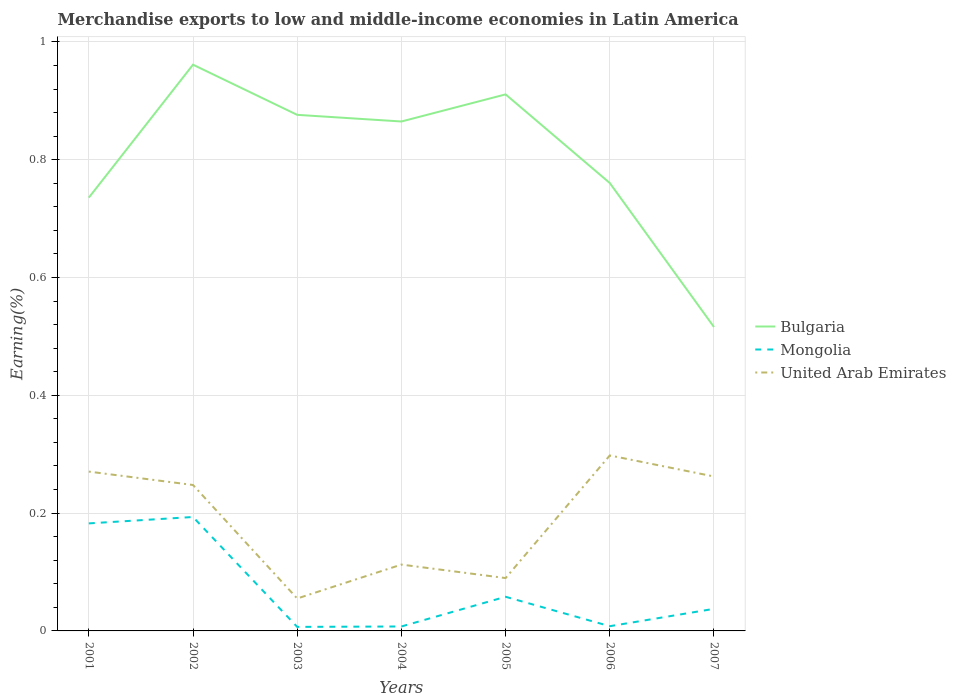How many different coloured lines are there?
Offer a very short reply. 3. Does the line corresponding to Bulgaria intersect with the line corresponding to United Arab Emirates?
Give a very brief answer. No. Is the number of lines equal to the number of legend labels?
Your answer should be compact. Yes. Across all years, what is the maximum percentage of amount earned from merchandise exports in United Arab Emirates?
Ensure brevity in your answer.  0.06. In which year was the percentage of amount earned from merchandise exports in United Arab Emirates maximum?
Provide a short and direct response. 2003. What is the total percentage of amount earned from merchandise exports in Mongolia in the graph?
Give a very brief answer. 0.02. What is the difference between the highest and the second highest percentage of amount earned from merchandise exports in Mongolia?
Offer a terse response. 0.19. Is the percentage of amount earned from merchandise exports in Bulgaria strictly greater than the percentage of amount earned from merchandise exports in United Arab Emirates over the years?
Keep it short and to the point. No. How many years are there in the graph?
Provide a short and direct response. 7. What is the difference between two consecutive major ticks on the Y-axis?
Provide a short and direct response. 0.2. How many legend labels are there?
Ensure brevity in your answer.  3. How are the legend labels stacked?
Make the answer very short. Vertical. What is the title of the graph?
Provide a short and direct response. Merchandise exports to low and middle-income economies in Latin America. Does "Madagascar" appear as one of the legend labels in the graph?
Your answer should be very brief. No. What is the label or title of the Y-axis?
Offer a terse response. Earning(%). What is the Earning(%) of Bulgaria in 2001?
Provide a succinct answer. 0.74. What is the Earning(%) of Mongolia in 2001?
Offer a terse response. 0.18. What is the Earning(%) in United Arab Emirates in 2001?
Make the answer very short. 0.27. What is the Earning(%) of Bulgaria in 2002?
Keep it short and to the point. 0.96. What is the Earning(%) in Mongolia in 2002?
Ensure brevity in your answer.  0.19. What is the Earning(%) in United Arab Emirates in 2002?
Offer a very short reply. 0.25. What is the Earning(%) in Bulgaria in 2003?
Ensure brevity in your answer.  0.88. What is the Earning(%) in Mongolia in 2003?
Offer a very short reply. 0.01. What is the Earning(%) in United Arab Emirates in 2003?
Your answer should be very brief. 0.06. What is the Earning(%) of Bulgaria in 2004?
Provide a short and direct response. 0.86. What is the Earning(%) in Mongolia in 2004?
Give a very brief answer. 0.01. What is the Earning(%) of United Arab Emirates in 2004?
Ensure brevity in your answer.  0.11. What is the Earning(%) of Bulgaria in 2005?
Ensure brevity in your answer.  0.91. What is the Earning(%) of Mongolia in 2005?
Provide a succinct answer. 0.06. What is the Earning(%) in United Arab Emirates in 2005?
Make the answer very short. 0.09. What is the Earning(%) of Bulgaria in 2006?
Ensure brevity in your answer.  0.76. What is the Earning(%) of Mongolia in 2006?
Keep it short and to the point. 0.01. What is the Earning(%) in United Arab Emirates in 2006?
Provide a short and direct response. 0.3. What is the Earning(%) in Bulgaria in 2007?
Your response must be concise. 0.52. What is the Earning(%) in Mongolia in 2007?
Offer a very short reply. 0.04. What is the Earning(%) of United Arab Emirates in 2007?
Provide a succinct answer. 0.26. Across all years, what is the maximum Earning(%) in Bulgaria?
Provide a short and direct response. 0.96. Across all years, what is the maximum Earning(%) of Mongolia?
Make the answer very short. 0.19. Across all years, what is the maximum Earning(%) of United Arab Emirates?
Offer a very short reply. 0.3. Across all years, what is the minimum Earning(%) in Bulgaria?
Give a very brief answer. 0.52. Across all years, what is the minimum Earning(%) in Mongolia?
Your response must be concise. 0.01. Across all years, what is the minimum Earning(%) in United Arab Emirates?
Make the answer very short. 0.06. What is the total Earning(%) in Bulgaria in the graph?
Give a very brief answer. 5.62. What is the total Earning(%) of Mongolia in the graph?
Keep it short and to the point. 0.49. What is the total Earning(%) in United Arab Emirates in the graph?
Provide a short and direct response. 1.34. What is the difference between the Earning(%) of Bulgaria in 2001 and that in 2002?
Provide a short and direct response. -0.23. What is the difference between the Earning(%) of Mongolia in 2001 and that in 2002?
Provide a short and direct response. -0.01. What is the difference between the Earning(%) of United Arab Emirates in 2001 and that in 2002?
Your response must be concise. 0.02. What is the difference between the Earning(%) in Bulgaria in 2001 and that in 2003?
Your answer should be compact. -0.14. What is the difference between the Earning(%) of Mongolia in 2001 and that in 2003?
Your answer should be very brief. 0.18. What is the difference between the Earning(%) in United Arab Emirates in 2001 and that in 2003?
Your answer should be compact. 0.22. What is the difference between the Earning(%) of Bulgaria in 2001 and that in 2004?
Your answer should be compact. -0.13. What is the difference between the Earning(%) in Mongolia in 2001 and that in 2004?
Keep it short and to the point. 0.17. What is the difference between the Earning(%) of United Arab Emirates in 2001 and that in 2004?
Your response must be concise. 0.16. What is the difference between the Earning(%) of Bulgaria in 2001 and that in 2005?
Make the answer very short. -0.18. What is the difference between the Earning(%) of Mongolia in 2001 and that in 2005?
Ensure brevity in your answer.  0.12. What is the difference between the Earning(%) in United Arab Emirates in 2001 and that in 2005?
Offer a very short reply. 0.18. What is the difference between the Earning(%) of Bulgaria in 2001 and that in 2006?
Provide a succinct answer. -0.02. What is the difference between the Earning(%) in Mongolia in 2001 and that in 2006?
Your answer should be very brief. 0.17. What is the difference between the Earning(%) in United Arab Emirates in 2001 and that in 2006?
Keep it short and to the point. -0.03. What is the difference between the Earning(%) in Bulgaria in 2001 and that in 2007?
Provide a succinct answer. 0.22. What is the difference between the Earning(%) in Mongolia in 2001 and that in 2007?
Offer a very short reply. 0.15. What is the difference between the Earning(%) of United Arab Emirates in 2001 and that in 2007?
Offer a terse response. 0.01. What is the difference between the Earning(%) in Bulgaria in 2002 and that in 2003?
Give a very brief answer. 0.09. What is the difference between the Earning(%) of Mongolia in 2002 and that in 2003?
Make the answer very short. 0.19. What is the difference between the Earning(%) in United Arab Emirates in 2002 and that in 2003?
Your answer should be very brief. 0.19. What is the difference between the Earning(%) of Bulgaria in 2002 and that in 2004?
Ensure brevity in your answer.  0.1. What is the difference between the Earning(%) in Mongolia in 2002 and that in 2004?
Keep it short and to the point. 0.19. What is the difference between the Earning(%) in United Arab Emirates in 2002 and that in 2004?
Your response must be concise. 0.14. What is the difference between the Earning(%) in Bulgaria in 2002 and that in 2005?
Offer a very short reply. 0.05. What is the difference between the Earning(%) in Mongolia in 2002 and that in 2005?
Provide a short and direct response. 0.14. What is the difference between the Earning(%) of United Arab Emirates in 2002 and that in 2005?
Your answer should be very brief. 0.16. What is the difference between the Earning(%) of Bulgaria in 2002 and that in 2006?
Ensure brevity in your answer.  0.2. What is the difference between the Earning(%) in Mongolia in 2002 and that in 2006?
Your response must be concise. 0.19. What is the difference between the Earning(%) in United Arab Emirates in 2002 and that in 2006?
Make the answer very short. -0.05. What is the difference between the Earning(%) of Bulgaria in 2002 and that in 2007?
Give a very brief answer. 0.45. What is the difference between the Earning(%) in Mongolia in 2002 and that in 2007?
Your answer should be very brief. 0.16. What is the difference between the Earning(%) of United Arab Emirates in 2002 and that in 2007?
Offer a terse response. -0.01. What is the difference between the Earning(%) in Bulgaria in 2003 and that in 2004?
Make the answer very short. 0.01. What is the difference between the Earning(%) of Mongolia in 2003 and that in 2004?
Provide a succinct answer. -0. What is the difference between the Earning(%) of United Arab Emirates in 2003 and that in 2004?
Provide a short and direct response. -0.06. What is the difference between the Earning(%) of Bulgaria in 2003 and that in 2005?
Provide a succinct answer. -0.03. What is the difference between the Earning(%) in Mongolia in 2003 and that in 2005?
Offer a terse response. -0.05. What is the difference between the Earning(%) of United Arab Emirates in 2003 and that in 2005?
Ensure brevity in your answer.  -0.03. What is the difference between the Earning(%) of Bulgaria in 2003 and that in 2006?
Your response must be concise. 0.12. What is the difference between the Earning(%) of Mongolia in 2003 and that in 2006?
Provide a succinct answer. -0. What is the difference between the Earning(%) of United Arab Emirates in 2003 and that in 2006?
Your answer should be very brief. -0.24. What is the difference between the Earning(%) in Bulgaria in 2003 and that in 2007?
Keep it short and to the point. 0.36. What is the difference between the Earning(%) in Mongolia in 2003 and that in 2007?
Your answer should be very brief. -0.03. What is the difference between the Earning(%) in United Arab Emirates in 2003 and that in 2007?
Provide a short and direct response. -0.21. What is the difference between the Earning(%) in Bulgaria in 2004 and that in 2005?
Offer a terse response. -0.05. What is the difference between the Earning(%) of Mongolia in 2004 and that in 2005?
Provide a succinct answer. -0.05. What is the difference between the Earning(%) of United Arab Emirates in 2004 and that in 2005?
Offer a very short reply. 0.02. What is the difference between the Earning(%) in Bulgaria in 2004 and that in 2006?
Your answer should be compact. 0.1. What is the difference between the Earning(%) in Mongolia in 2004 and that in 2006?
Provide a succinct answer. -0. What is the difference between the Earning(%) in United Arab Emirates in 2004 and that in 2006?
Your response must be concise. -0.19. What is the difference between the Earning(%) in Bulgaria in 2004 and that in 2007?
Keep it short and to the point. 0.35. What is the difference between the Earning(%) in Mongolia in 2004 and that in 2007?
Make the answer very short. -0.03. What is the difference between the Earning(%) in United Arab Emirates in 2004 and that in 2007?
Your response must be concise. -0.15. What is the difference between the Earning(%) of Bulgaria in 2005 and that in 2006?
Provide a short and direct response. 0.15. What is the difference between the Earning(%) of Mongolia in 2005 and that in 2006?
Keep it short and to the point. 0.05. What is the difference between the Earning(%) in United Arab Emirates in 2005 and that in 2006?
Your answer should be compact. -0.21. What is the difference between the Earning(%) of Bulgaria in 2005 and that in 2007?
Make the answer very short. 0.4. What is the difference between the Earning(%) in Mongolia in 2005 and that in 2007?
Provide a succinct answer. 0.02. What is the difference between the Earning(%) of United Arab Emirates in 2005 and that in 2007?
Provide a short and direct response. -0.17. What is the difference between the Earning(%) of Bulgaria in 2006 and that in 2007?
Your response must be concise. 0.24. What is the difference between the Earning(%) of Mongolia in 2006 and that in 2007?
Your answer should be compact. -0.03. What is the difference between the Earning(%) of United Arab Emirates in 2006 and that in 2007?
Keep it short and to the point. 0.04. What is the difference between the Earning(%) in Bulgaria in 2001 and the Earning(%) in Mongolia in 2002?
Offer a very short reply. 0.54. What is the difference between the Earning(%) of Bulgaria in 2001 and the Earning(%) of United Arab Emirates in 2002?
Your answer should be very brief. 0.49. What is the difference between the Earning(%) in Mongolia in 2001 and the Earning(%) in United Arab Emirates in 2002?
Provide a short and direct response. -0.07. What is the difference between the Earning(%) of Bulgaria in 2001 and the Earning(%) of Mongolia in 2003?
Give a very brief answer. 0.73. What is the difference between the Earning(%) in Bulgaria in 2001 and the Earning(%) in United Arab Emirates in 2003?
Provide a short and direct response. 0.68. What is the difference between the Earning(%) in Mongolia in 2001 and the Earning(%) in United Arab Emirates in 2003?
Your response must be concise. 0.13. What is the difference between the Earning(%) of Bulgaria in 2001 and the Earning(%) of Mongolia in 2004?
Offer a terse response. 0.73. What is the difference between the Earning(%) of Bulgaria in 2001 and the Earning(%) of United Arab Emirates in 2004?
Offer a very short reply. 0.62. What is the difference between the Earning(%) in Mongolia in 2001 and the Earning(%) in United Arab Emirates in 2004?
Ensure brevity in your answer.  0.07. What is the difference between the Earning(%) of Bulgaria in 2001 and the Earning(%) of Mongolia in 2005?
Your response must be concise. 0.68. What is the difference between the Earning(%) of Bulgaria in 2001 and the Earning(%) of United Arab Emirates in 2005?
Your answer should be very brief. 0.65. What is the difference between the Earning(%) in Mongolia in 2001 and the Earning(%) in United Arab Emirates in 2005?
Provide a succinct answer. 0.09. What is the difference between the Earning(%) in Bulgaria in 2001 and the Earning(%) in Mongolia in 2006?
Offer a very short reply. 0.73. What is the difference between the Earning(%) of Bulgaria in 2001 and the Earning(%) of United Arab Emirates in 2006?
Offer a terse response. 0.44. What is the difference between the Earning(%) of Mongolia in 2001 and the Earning(%) of United Arab Emirates in 2006?
Ensure brevity in your answer.  -0.12. What is the difference between the Earning(%) in Bulgaria in 2001 and the Earning(%) in Mongolia in 2007?
Offer a terse response. 0.7. What is the difference between the Earning(%) of Bulgaria in 2001 and the Earning(%) of United Arab Emirates in 2007?
Your answer should be very brief. 0.47. What is the difference between the Earning(%) in Mongolia in 2001 and the Earning(%) in United Arab Emirates in 2007?
Offer a very short reply. -0.08. What is the difference between the Earning(%) of Bulgaria in 2002 and the Earning(%) of Mongolia in 2003?
Ensure brevity in your answer.  0.95. What is the difference between the Earning(%) in Bulgaria in 2002 and the Earning(%) in United Arab Emirates in 2003?
Give a very brief answer. 0.91. What is the difference between the Earning(%) in Mongolia in 2002 and the Earning(%) in United Arab Emirates in 2003?
Provide a short and direct response. 0.14. What is the difference between the Earning(%) in Bulgaria in 2002 and the Earning(%) in Mongolia in 2004?
Provide a short and direct response. 0.95. What is the difference between the Earning(%) in Bulgaria in 2002 and the Earning(%) in United Arab Emirates in 2004?
Your response must be concise. 0.85. What is the difference between the Earning(%) in Mongolia in 2002 and the Earning(%) in United Arab Emirates in 2004?
Give a very brief answer. 0.08. What is the difference between the Earning(%) in Bulgaria in 2002 and the Earning(%) in Mongolia in 2005?
Offer a terse response. 0.9. What is the difference between the Earning(%) in Bulgaria in 2002 and the Earning(%) in United Arab Emirates in 2005?
Give a very brief answer. 0.87. What is the difference between the Earning(%) in Mongolia in 2002 and the Earning(%) in United Arab Emirates in 2005?
Your answer should be compact. 0.1. What is the difference between the Earning(%) of Bulgaria in 2002 and the Earning(%) of Mongolia in 2006?
Ensure brevity in your answer.  0.95. What is the difference between the Earning(%) in Bulgaria in 2002 and the Earning(%) in United Arab Emirates in 2006?
Make the answer very short. 0.66. What is the difference between the Earning(%) in Mongolia in 2002 and the Earning(%) in United Arab Emirates in 2006?
Ensure brevity in your answer.  -0.1. What is the difference between the Earning(%) of Bulgaria in 2002 and the Earning(%) of Mongolia in 2007?
Offer a terse response. 0.92. What is the difference between the Earning(%) of Bulgaria in 2002 and the Earning(%) of United Arab Emirates in 2007?
Your answer should be very brief. 0.7. What is the difference between the Earning(%) in Mongolia in 2002 and the Earning(%) in United Arab Emirates in 2007?
Keep it short and to the point. -0.07. What is the difference between the Earning(%) in Bulgaria in 2003 and the Earning(%) in Mongolia in 2004?
Make the answer very short. 0.87. What is the difference between the Earning(%) in Bulgaria in 2003 and the Earning(%) in United Arab Emirates in 2004?
Your answer should be very brief. 0.76. What is the difference between the Earning(%) of Mongolia in 2003 and the Earning(%) of United Arab Emirates in 2004?
Your answer should be very brief. -0.11. What is the difference between the Earning(%) in Bulgaria in 2003 and the Earning(%) in Mongolia in 2005?
Make the answer very short. 0.82. What is the difference between the Earning(%) in Bulgaria in 2003 and the Earning(%) in United Arab Emirates in 2005?
Keep it short and to the point. 0.79. What is the difference between the Earning(%) of Mongolia in 2003 and the Earning(%) of United Arab Emirates in 2005?
Keep it short and to the point. -0.08. What is the difference between the Earning(%) of Bulgaria in 2003 and the Earning(%) of Mongolia in 2006?
Offer a terse response. 0.87. What is the difference between the Earning(%) of Bulgaria in 2003 and the Earning(%) of United Arab Emirates in 2006?
Your answer should be very brief. 0.58. What is the difference between the Earning(%) in Mongolia in 2003 and the Earning(%) in United Arab Emirates in 2006?
Make the answer very short. -0.29. What is the difference between the Earning(%) of Bulgaria in 2003 and the Earning(%) of Mongolia in 2007?
Your answer should be very brief. 0.84. What is the difference between the Earning(%) in Bulgaria in 2003 and the Earning(%) in United Arab Emirates in 2007?
Your answer should be compact. 0.61. What is the difference between the Earning(%) of Mongolia in 2003 and the Earning(%) of United Arab Emirates in 2007?
Ensure brevity in your answer.  -0.26. What is the difference between the Earning(%) in Bulgaria in 2004 and the Earning(%) in Mongolia in 2005?
Your answer should be compact. 0.81. What is the difference between the Earning(%) of Bulgaria in 2004 and the Earning(%) of United Arab Emirates in 2005?
Keep it short and to the point. 0.78. What is the difference between the Earning(%) of Mongolia in 2004 and the Earning(%) of United Arab Emirates in 2005?
Offer a very short reply. -0.08. What is the difference between the Earning(%) of Bulgaria in 2004 and the Earning(%) of Mongolia in 2006?
Ensure brevity in your answer.  0.86. What is the difference between the Earning(%) in Bulgaria in 2004 and the Earning(%) in United Arab Emirates in 2006?
Provide a short and direct response. 0.57. What is the difference between the Earning(%) in Mongolia in 2004 and the Earning(%) in United Arab Emirates in 2006?
Your answer should be compact. -0.29. What is the difference between the Earning(%) in Bulgaria in 2004 and the Earning(%) in Mongolia in 2007?
Provide a succinct answer. 0.83. What is the difference between the Earning(%) of Bulgaria in 2004 and the Earning(%) of United Arab Emirates in 2007?
Keep it short and to the point. 0.6. What is the difference between the Earning(%) of Mongolia in 2004 and the Earning(%) of United Arab Emirates in 2007?
Make the answer very short. -0.25. What is the difference between the Earning(%) of Bulgaria in 2005 and the Earning(%) of Mongolia in 2006?
Keep it short and to the point. 0.9. What is the difference between the Earning(%) in Bulgaria in 2005 and the Earning(%) in United Arab Emirates in 2006?
Keep it short and to the point. 0.61. What is the difference between the Earning(%) in Mongolia in 2005 and the Earning(%) in United Arab Emirates in 2006?
Provide a succinct answer. -0.24. What is the difference between the Earning(%) in Bulgaria in 2005 and the Earning(%) in Mongolia in 2007?
Your response must be concise. 0.87. What is the difference between the Earning(%) in Bulgaria in 2005 and the Earning(%) in United Arab Emirates in 2007?
Your response must be concise. 0.65. What is the difference between the Earning(%) of Mongolia in 2005 and the Earning(%) of United Arab Emirates in 2007?
Your answer should be very brief. -0.2. What is the difference between the Earning(%) in Bulgaria in 2006 and the Earning(%) in Mongolia in 2007?
Your answer should be very brief. 0.72. What is the difference between the Earning(%) of Bulgaria in 2006 and the Earning(%) of United Arab Emirates in 2007?
Provide a succinct answer. 0.5. What is the difference between the Earning(%) of Mongolia in 2006 and the Earning(%) of United Arab Emirates in 2007?
Provide a succinct answer. -0.25. What is the average Earning(%) in Bulgaria per year?
Keep it short and to the point. 0.8. What is the average Earning(%) of Mongolia per year?
Your response must be concise. 0.07. What is the average Earning(%) of United Arab Emirates per year?
Ensure brevity in your answer.  0.19. In the year 2001, what is the difference between the Earning(%) of Bulgaria and Earning(%) of Mongolia?
Give a very brief answer. 0.55. In the year 2001, what is the difference between the Earning(%) of Bulgaria and Earning(%) of United Arab Emirates?
Ensure brevity in your answer.  0.47. In the year 2001, what is the difference between the Earning(%) of Mongolia and Earning(%) of United Arab Emirates?
Give a very brief answer. -0.09. In the year 2002, what is the difference between the Earning(%) in Bulgaria and Earning(%) in Mongolia?
Keep it short and to the point. 0.77. In the year 2002, what is the difference between the Earning(%) of Bulgaria and Earning(%) of United Arab Emirates?
Provide a succinct answer. 0.71. In the year 2002, what is the difference between the Earning(%) in Mongolia and Earning(%) in United Arab Emirates?
Make the answer very short. -0.05. In the year 2003, what is the difference between the Earning(%) in Bulgaria and Earning(%) in Mongolia?
Your answer should be compact. 0.87. In the year 2003, what is the difference between the Earning(%) of Bulgaria and Earning(%) of United Arab Emirates?
Offer a very short reply. 0.82. In the year 2003, what is the difference between the Earning(%) of Mongolia and Earning(%) of United Arab Emirates?
Provide a succinct answer. -0.05. In the year 2004, what is the difference between the Earning(%) of Bulgaria and Earning(%) of Mongolia?
Provide a short and direct response. 0.86. In the year 2004, what is the difference between the Earning(%) in Bulgaria and Earning(%) in United Arab Emirates?
Keep it short and to the point. 0.75. In the year 2004, what is the difference between the Earning(%) of Mongolia and Earning(%) of United Arab Emirates?
Keep it short and to the point. -0.11. In the year 2005, what is the difference between the Earning(%) in Bulgaria and Earning(%) in Mongolia?
Ensure brevity in your answer.  0.85. In the year 2005, what is the difference between the Earning(%) of Bulgaria and Earning(%) of United Arab Emirates?
Ensure brevity in your answer.  0.82. In the year 2005, what is the difference between the Earning(%) of Mongolia and Earning(%) of United Arab Emirates?
Give a very brief answer. -0.03. In the year 2006, what is the difference between the Earning(%) of Bulgaria and Earning(%) of Mongolia?
Give a very brief answer. 0.75. In the year 2006, what is the difference between the Earning(%) of Bulgaria and Earning(%) of United Arab Emirates?
Ensure brevity in your answer.  0.46. In the year 2006, what is the difference between the Earning(%) of Mongolia and Earning(%) of United Arab Emirates?
Give a very brief answer. -0.29. In the year 2007, what is the difference between the Earning(%) in Bulgaria and Earning(%) in Mongolia?
Provide a succinct answer. 0.48. In the year 2007, what is the difference between the Earning(%) in Bulgaria and Earning(%) in United Arab Emirates?
Your response must be concise. 0.25. In the year 2007, what is the difference between the Earning(%) of Mongolia and Earning(%) of United Arab Emirates?
Make the answer very short. -0.22. What is the ratio of the Earning(%) of Bulgaria in 2001 to that in 2002?
Your response must be concise. 0.77. What is the ratio of the Earning(%) in Mongolia in 2001 to that in 2002?
Your answer should be compact. 0.94. What is the ratio of the Earning(%) in United Arab Emirates in 2001 to that in 2002?
Offer a terse response. 1.09. What is the ratio of the Earning(%) of Bulgaria in 2001 to that in 2003?
Your answer should be compact. 0.84. What is the ratio of the Earning(%) of Mongolia in 2001 to that in 2003?
Provide a succinct answer. 26.68. What is the ratio of the Earning(%) in United Arab Emirates in 2001 to that in 2003?
Give a very brief answer. 4.91. What is the ratio of the Earning(%) in Bulgaria in 2001 to that in 2004?
Provide a succinct answer. 0.85. What is the ratio of the Earning(%) in Mongolia in 2001 to that in 2004?
Give a very brief answer. 24.19. What is the ratio of the Earning(%) in United Arab Emirates in 2001 to that in 2004?
Your response must be concise. 2.4. What is the ratio of the Earning(%) of Bulgaria in 2001 to that in 2005?
Provide a succinct answer. 0.81. What is the ratio of the Earning(%) of Mongolia in 2001 to that in 2005?
Your response must be concise. 3.15. What is the ratio of the Earning(%) of United Arab Emirates in 2001 to that in 2005?
Ensure brevity in your answer.  3.01. What is the ratio of the Earning(%) of Bulgaria in 2001 to that in 2006?
Provide a succinct answer. 0.97. What is the ratio of the Earning(%) in Mongolia in 2001 to that in 2006?
Ensure brevity in your answer.  22.76. What is the ratio of the Earning(%) of United Arab Emirates in 2001 to that in 2006?
Your answer should be very brief. 0.91. What is the ratio of the Earning(%) of Bulgaria in 2001 to that in 2007?
Offer a very short reply. 1.43. What is the ratio of the Earning(%) of Mongolia in 2001 to that in 2007?
Ensure brevity in your answer.  4.87. What is the ratio of the Earning(%) of United Arab Emirates in 2001 to that in 2007?
Offer a terse response. 1.03. What is the ratio of the Earning(%) in Bulgaria in 2002 to that in 2003?
Keep it short and to the point. 1.1. What is the ratio of the Earning(%) of Mongolia in 2002 to that in 2003?
Give a very brief answer. 28.27. What is the ratio of the Earning(%) in United Arab Emirates in 2002 to that in 2003?
Provide a succinct answer. 4.5. What is the ratio of the Earning(%) in Bulgaria in 2002 to that in 2004?
Give a very brief answer. 1.11. What is the ratio of the Earning(%) of Mongolia in 2002 to that in 2004?
Offer a very short reply. 25.62. What is the ratio of the Earning(%) in United Arab Emirates in 2002 to that in 2004?
Your answer should be very brief. 2.2. What is the ratio of the Earning(%) of Bulgaria in 2002 to that in 2005?
Your answer should be compact. 1.06. What is the ratio of the Earning(%) of Mongolia in 2002 to that in 2005?
Offer a terse response. 3.34. What is the ratio of the Earning(%) in United Arab Emirates in 2002 to that in 2005?
Make the answer very short. 2.76. What is the ratio of the Earning(%) of Bulgaria in 2002 to that in 2006?
Provide a short and direct response. 1.26. What is the ratio of the Earning(%) of Mongolia in 2002 to that in 2006?
Offer a terse response. 24.11. What is the ratio of the Earning(%) in United Arab Emirates in 2002 to that in 2006?
Your answer should be compact. 0.83. What is the ratio of the Earning(%) of Bulgaria in 2002 to that in 2007?
Your answer should be compact. 1.86. What is the ratio of the Earning(%) in Mongolia in 2002 to that in 2007?
Give a very brief answer. 5.16. What is the ratio of the Earning(%) in United Arab Emirates in 2002 to that in 2007?
Ensure brevity in your answer.  0.94. What is the ratio of the Earning(%) in Mongolia in 2003 to that in 2004?
Give a very brief answer. 0.91. What is the ratio of the Earning(%) of United Arab Emirates in 2003 to that in 2004?
Offer a terse response. 0.49. What is the ratio of the Earning(%) in Bulgaria in 2003 to that in 2005?
Provide a short and direct response. 0.96. What is the ratio of the Earning(%) of Mongolia in 2003 to that in 2005?
Ensure brevity in your answer.  0.12. What is the ratio of the Earning(%) in United Arab Emirates in 2003 to that in 2005?
Your response must be concise. 0.61. What is the ratio of the Earning(%) in Bulgaria in 2003 to that in 2006?
Provide a succinct answer. 1.15. What is the ratio of the Earning(%) of Mongolia in 2003 to that in 2006?
Offer a very short reply. 0.85. What is the ratio of the Earning(%) in United Arab Emirates in 2003 to that in 2006?
Ensure brevity in your answer.  0.18. What is the ratio of the Earning(%) in Bulgaria in 2003 to that in 2007?
Your answer should be very brief. 1.7. What is the ratio of the Earning(%) of Mongolia in 2003 to that in 2007?
Provide a succinct answer. 0.18. What is the ratio of the Earning(%) in United Arab Emirates in 2003 to that in 2007?
Ensure brevity in your answer.  0.21. What is the ratio of the Earning(%) in Bulgaria in 2004 to that in 2005?
Keep it short and to the point. 0.95. What is the ratio of the Earning(%) in Mongolia in 2004 to that in 2005?
Your response must be concise. 0.13. What is the ratio of the Earning(%) of United Arab Emirates in 2004 to that in 2005?
Give a very brief answer. 1.26. What is the ratio of the Earning(%) in Bulgaria in 2004 to that in 2006?
Offer a terse response. 1.14. What is the ratio of the Earning(%) of Mongolia in 2004 to that in 2006?
Keep it short and to the point. 0.94. What is the ratio of the Earning(%) in United Arab Emirates in 2004 to that in 2006?
Your response must be concise. 0.38. What is the ratio of the Earning(%) of Bulgaria in 2004 to that in 2007?
Provide a succinct answer. 1.68. What is the ratio of the Earning(%) in Mongolia in 2004 to that in 2007?
Your answer should be very brief. 0.2. What is the ratio of the Earning(%) in United Arab Emirates in 2004 to that in 2007?
Your answer should be very brief. 0.43. What is the ratio of the Earning(%) in Bulgaria in 2005 to that in 2006?
Provide a succinct answer. 1.2. What is the ratio of the Earning(%) in Mongolia in 2005 to that in 2006?
Offer a very short reply. 7.23. What is the ratio of the Earning(%) of United Arab Emirates in 2005 to that in 2006?
Ensure brevity in your answer.  0.3. What is the ratio of the Earning(%) in Bulgaria in 2005 to that in 2007?
Offer a very short reply. 1.77. What is the ratio of the Earning(%) in Mongolia in 2005 to that in 2007?
Provide a short and direct response. 1.55. What is the ratio of the Earning(%) in United Arab Emirates in 2005 to that in 2007?
Your response must be concise. 0.34. What is the ratio of the Earning(%) in Bulgaria in 2006 to that in 2007?
Your answer should be very brief. 1.47. What is the ratio of the Earning(%) in Mongolia in 2006 to that in 2007?
Your response must be concise. 0.21. What is the ratio of the Earning(%) in United Arab Emirates in 2006 to that in 2007?
Make the answer very short. 1.14. What is the difference between the highest and the second highest Earning(%) of Bulgaria?
Offer a very short reply. 0.05. What is the difference between the highest and the second highest Earning(%) of Mongolia?
Your answer should be very brief. 0.01. What is the difference between the highest and the second highest Earning(%) of United Arab Emirates?
Provide a succinct answer. 0.03. What is the difference between the highest and the lowest Earning(%) in Bulgaria?
Provide a short and direct response. 0.45. What is the difference between the highest and the lowest Earning(%) in Mongolia?
Ensure brevity in your answer.  0.19. What is the difference between the highest and the lowest Earning(%) in United Arab Emirates?
Offer a terse response. 0.24. 